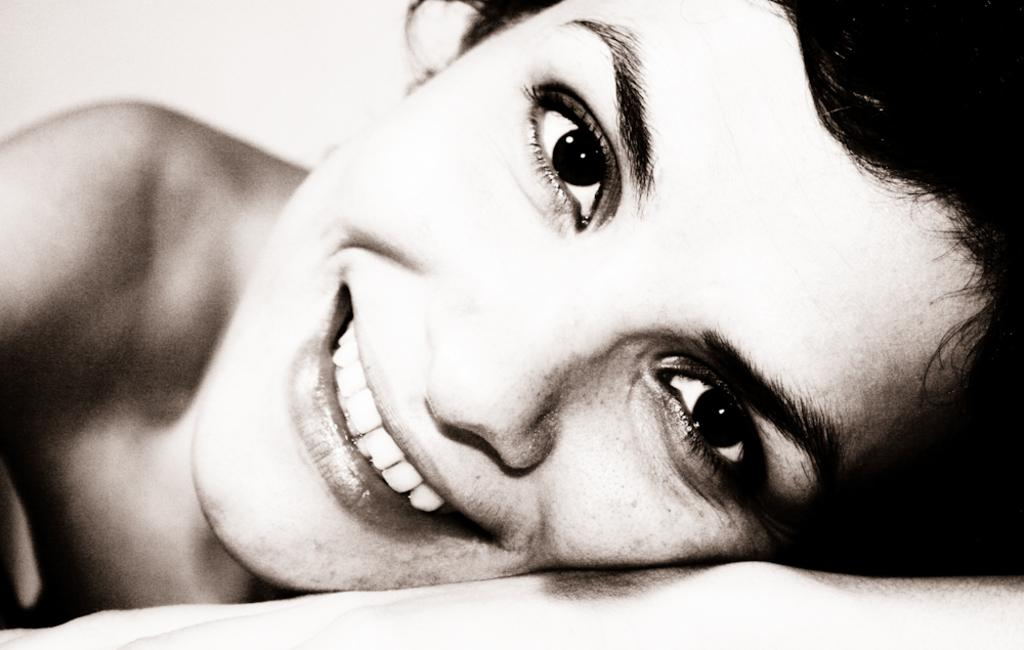What is the person in the image doing? The person in the image is lying down. What is the color of the background in the image? The background in the image is white. Can you see a fireman putting out a fire in the image? No, there is no fireman or fire present in the image. Are there any pears visible in the image? No, there are no pears present in the image. 